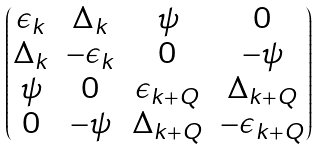<formula> <loc_0><loc_0><loc_500><loc_500>\begin{pmatrix} \epsilon _ { k } & \Delta _ { k } & \psi & 0 \\ \Delta _ { k } & - \epsilon _ { k } & 0 & - \psi \\ \psi & 0 & \epsilon _ { k + Q } & \Delta _ { k + Q } \\ 0 & - \psi & \Delta _ { k + Q } & - \epsilon _ { k + Q } \end{pmatrix}</formula> 